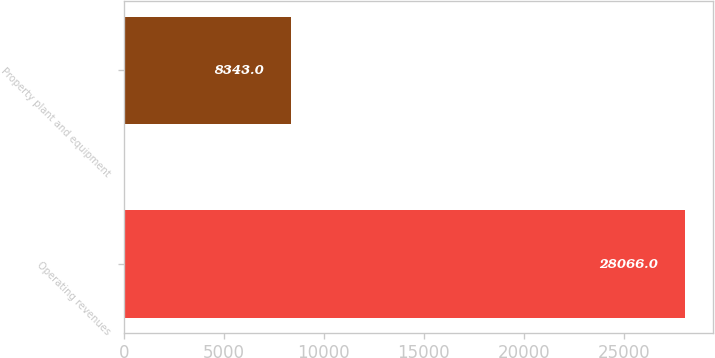<chart> <loc_0><loc_0><loc_500><loc_500><bar_chart><fcel>Operating revenues<fcel>Property plant and equipment<nl><fcel>28066<fcel>8343<nl></chart> 